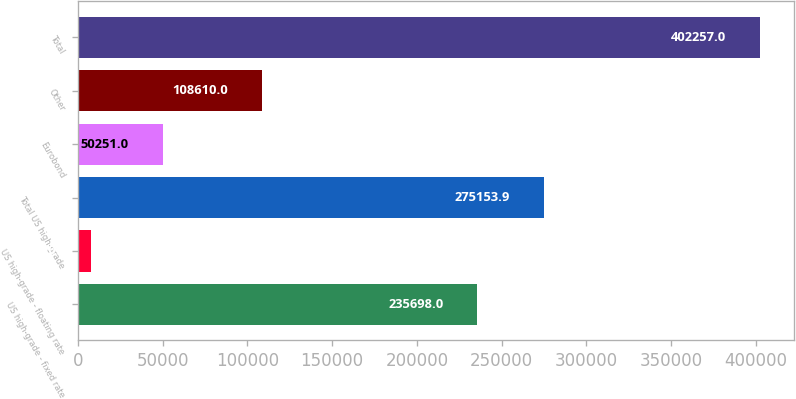Convert chart. <chart><loc_0><loc_0><loc_500><loc_500><bar_chart><fcel>US high-grade - fixed rate<fcel>US high-grade - floating rate<fcel>Total US high-grade<fcel>Eurobond<fcel>Other<fcel>Total<nl><fcel>235698<fcel>7698<fcel>275154<fcel>50251<fcel>108610<fcel>402257<nl></chart> 